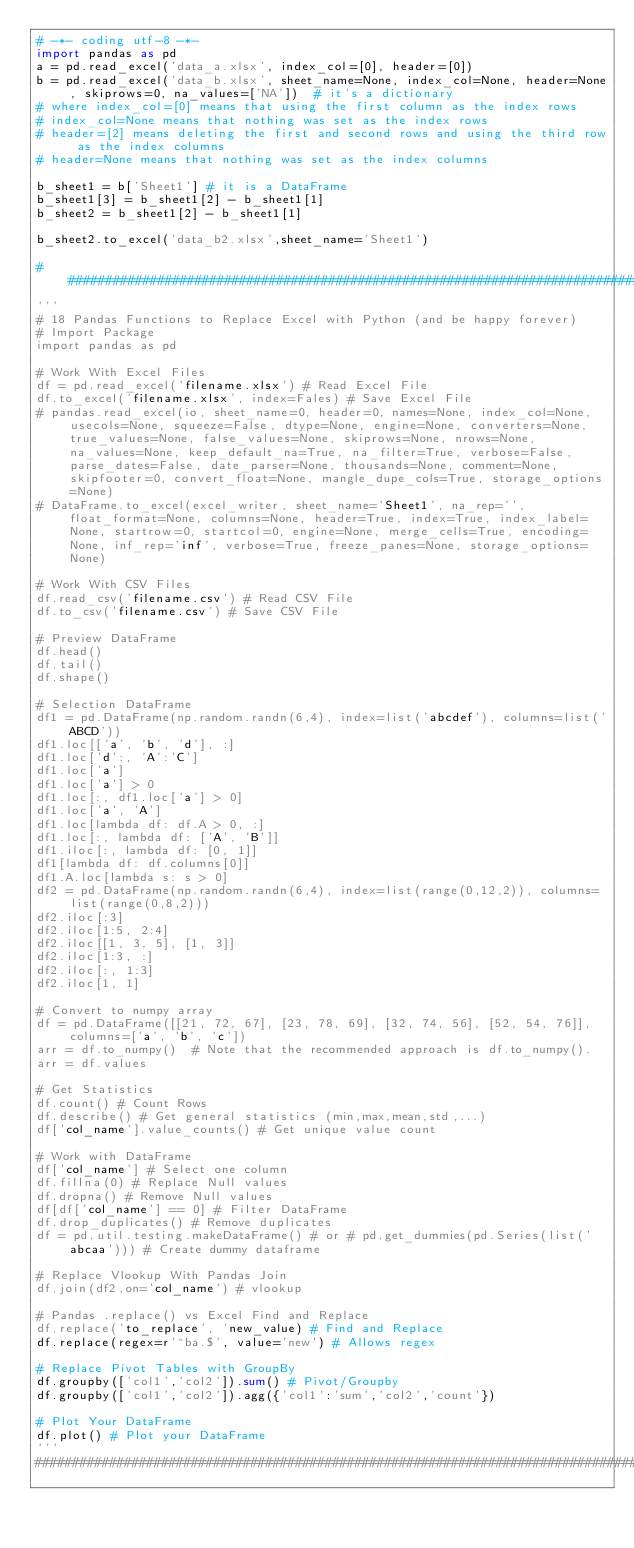<code> <loc_0><loc_0><loc_500><loc_500><_Python_># -*- coding utf-8 -*-
import pandas as pd
a = pd.read_excel('data_a.xlsx', index_col=[0], header=[0])
b = pd.read_excel('data_b.xlsx', sheet_name=None, index_col=None, header=None, skiprows=0, na_values=['NA'])  # it's a dictionary
# where index_col=[0] means that using the first column as the index rows
# index_col=None means that nothing was set as the index rows
# header=[2] means deleting the first and second rows and using the third row as the index columns
# header=None means that nothing was set as the index columns

b_sheet1 = b['Sheet1'] # it is a DataFrame
b_sheet1[3] = b_sheet1[2] - b_sheet1[1]
b_sheet2 = b_sheet1[2] - b_sheet1[1]

b_sheet2.to_excel('data_b2.xlsx',sheet_name='Sheet1')

##############################################################################################################
'''
# 18 Pandas Functions to Replace Excel with Python (and be happy forever)
# Import Package
import pandas as pd

# Work With Excel Files
df = pd.read_excel('filename.xlsx') # Read Excel File
df.to_excel('filename.xlsx', index=Fales) # Save Excel File
# pandas.read_excel(io, sheet_name=0, header=0, names=None, index_col=None, usecols=None, squeeze=False, dtype=None, engine=None, converters=None, true_values=None, false_values=None, skiprows=None, nrows=None, na_values=None, keep_default_na=True, na_filter=True, verbose=False, parse_dates=False, date_parser=None, thousands=None, comment=None, skipfooter=0, convert_float=None, mangle_dupe_cols=True, storage_options=None)
# DataFrame.to_excel(excel_writer, sheet_name='Sheet1', na_rep='', float_format=None, columns=None, header=True, index=True, index_label=None, startrow=0, startcol=0, engine=None, merge_cells=True, encoding=None, inf_rep='inf', verbose=True, freeze_panes=None, storage_options=None)

# Work With CSV Files
df.read_csv('filename.csv') # Read CSV File
df.to_csv('filename.csv') # Save CSV File

# Preview DataFrame
df.head()
df.tail()
df.shape()

# Selection DataFrame
df1 = pd.DataFrame(np.random.randn(6,4), index=list('abcdef'), columns=list('ABCD'))
df1.loc[['a', 'b', 'd'], :]
df1.loc['d':, 'A':'C']
df1.loc['a']
df1.loc['a'] > 0
df1.loc[:, df1.loc['a'] > 0]
df1.loc['a', 'A']
df1.loc[lambda df: df.A > 0, :]
df1.loc[:, lambda df: ['A', 'B']]
df1.iloc[:, lambda df: [0, 1]]
df1[lambda df: df.columns[0]]
df1.A.loc[lambda s: s > 0]
df2 = pd.DataFrame(np.random.randn(6,4), index=list(range(0,12,2)), columns=list(range(0,8,2)))
df2.iloc[:3]
df2.iloc[1:5, 2:4]
df2.iloc[[1, 3, 5], [1, 3]]
df2.iloc[1:3, :]
df2.iloc[:, 1:3]
df2.iloc[1, 1]

# Convert to numpy array
df = pd.DataFrame([[21, 72, 67], [23, 78, 69], [32, 74, 56], [52, 54, 76]],	columns=['a', 'b', 'c'])
arr = df.to_numpy()  # Note that the recommended approach is df.to_numpy().
arr = df.values

# Get Statistics
df.count() # Count Rows
df.describe() # Get general statistics (min,max,mean,std,...)
df['col_name'].value_counts() # Get unique value count

# Work with DataFrame
df['col_name'] # Select one column
df.fillna(0) # Replace Null values
df.dropna() # Remove Null values
df[df['col_name'] == 0] # Filter DataFrame
df.drop_duplicates() # Remove duplicates
df = pd.util.testing.makeDataFrame() # or # pd.get_dummies(pd.Series(list('abcaa'))) # Create dummy dataframe

# Replace Vlookup With Pandas Join
df.join(df2,on='col_name') # vlookup

# Pandas .replace() vs Excel Find and Replace
df.replace('to_replace', 'new_value) # Find and Replace
df.replace(regex=r'^ba.$', value='new') # Allows regex

# Replace Pivot Tables with GroupBy
df.groupby(['col1','col2']).sum() # Pivot/Groupby
df.groupby(['col1','col2']).agg({'col1':'sum','col2','count'})

# Plot Your DataFrame
df.plot() # Plot your DataFrame
'''
##############################################################################################################</code> 